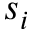<formula> <loc_0><loc_0><loc_500><loc_500>s _ { i }</formula> 